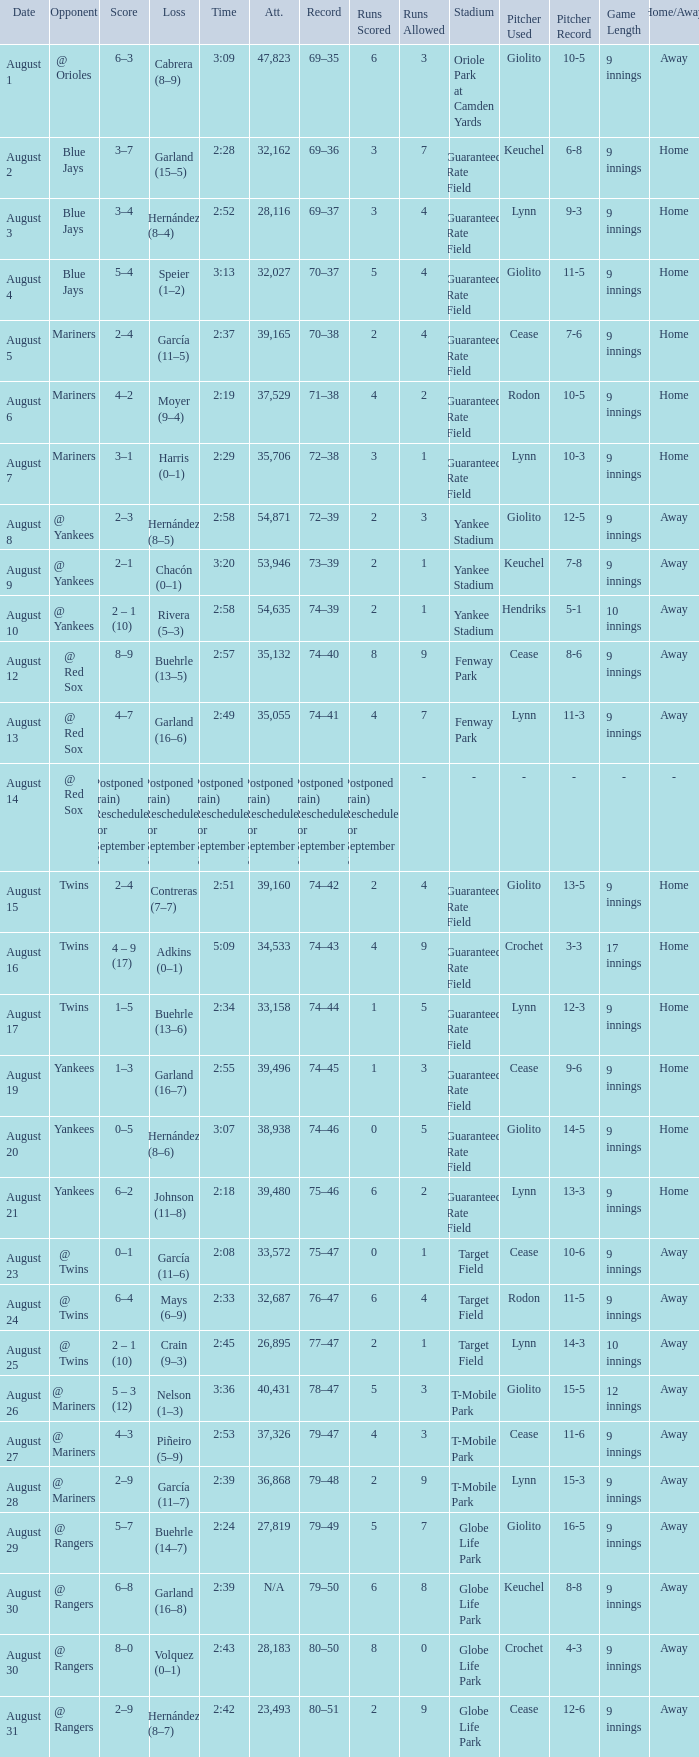Who lost on August 27? Piñeiro (5–9). 